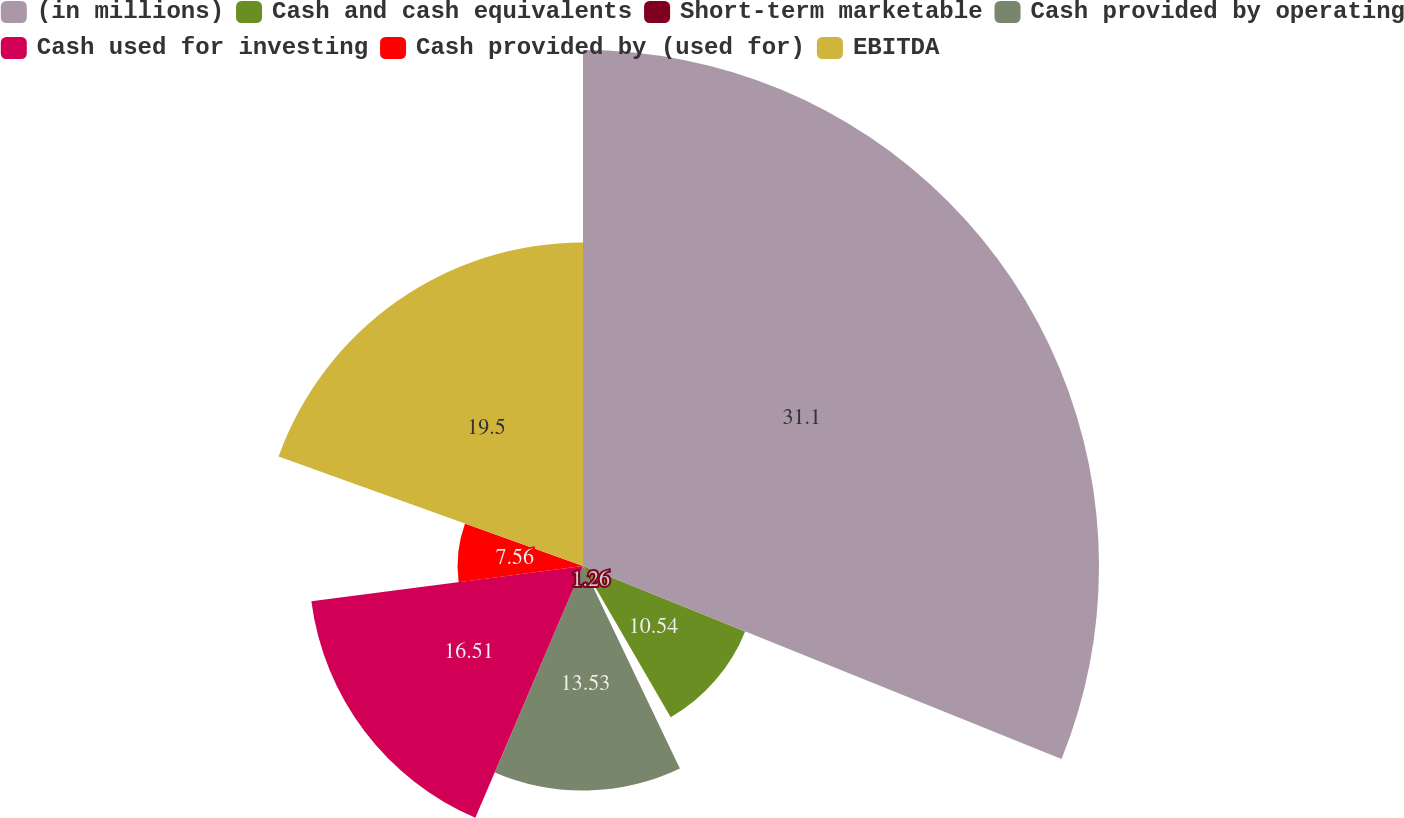Convert chart to OTSL. <chart><loc_0><loc_0><loc_500><loc_500><pie_chart><fcel>(in millions)<fcel>Cash and cash equivalents<fcel>Short-term marketable<fcel>Cash provided by operating<fcel>Cash used for investing<fcel>Cash provided by (used for)<fcel>EBITDA<nl><fcel>31.1%<fcel>10.54%<fcel>1.26%<fcel>13.53%<fcel>16.51%<fcel>7.56%<fcel>19.5%<nl></chart> 